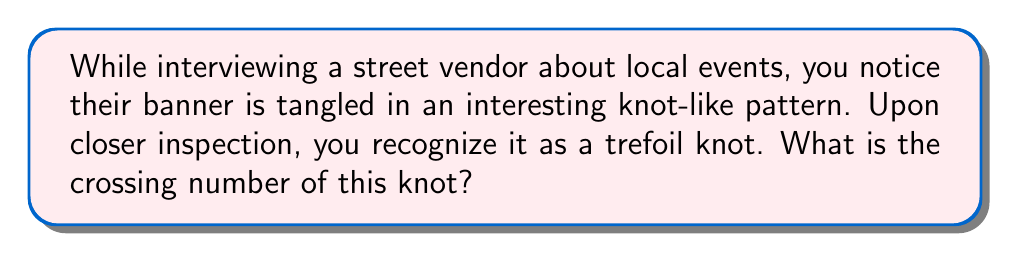Can you answer this question? To determine the crossing number of the trefoil knot, we need to follow these steps:

1. Understand the definition: The crossing number of a knot is the minimum number of crossings that occur in any projection of the knot onto a plane.

2. Visualize the trefoil knot: The trefoil knot is one of the simplest non-trivial knots.

3. Draw the minimal crossing diagram:
   [asy]
   import geometry;
   
   pair A = (0,1), B = (-0.866,-0.5), C = (0.866,-0.5);
   path p1 = A--B;
   path p2 = B--C;
   path p3 = C--A;
   
   draw(p1, p2+p3);
   draw(subpath(p2,0,0.5));
   draw(subpath(p3,0.5,1));
   draw(subpath(p2,0.5,1), dashed);
   draw(subpath(p3,0,0.5), dashed);
   
   dot(A); dot(B); dot(C);
   [/asy]

4. Count the crossings: In this minimal representation, we can clearly see that there are exactly 3 crossings.

5. Prove minimality: It can be mathematically proven that no projection of the trefoil knot can have fewer than 3 crossings, but this proof is beyond the scope of this explanation.

Therefore, the crossing number of the trefoil knot is 3.
Answer: 3 